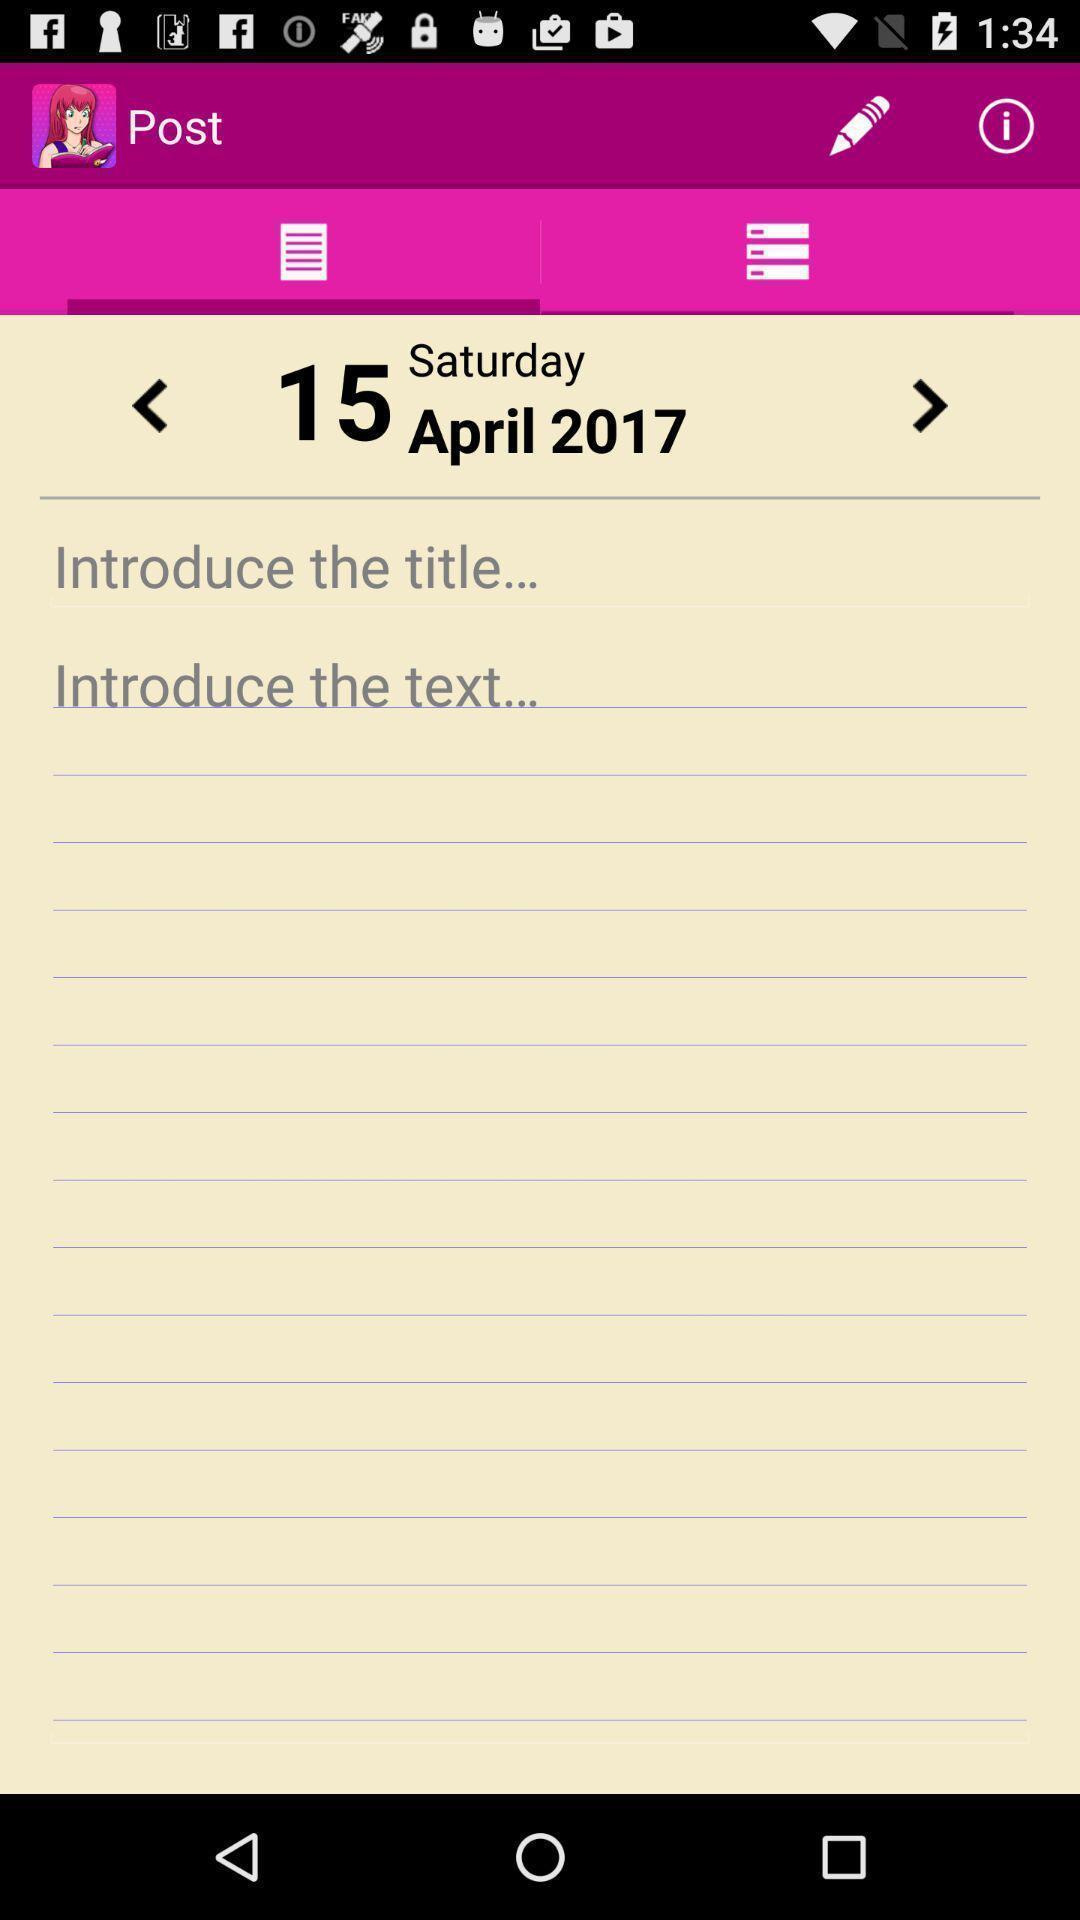Tell me about the visual elements in this screen capture. Screen showing note page with date. 